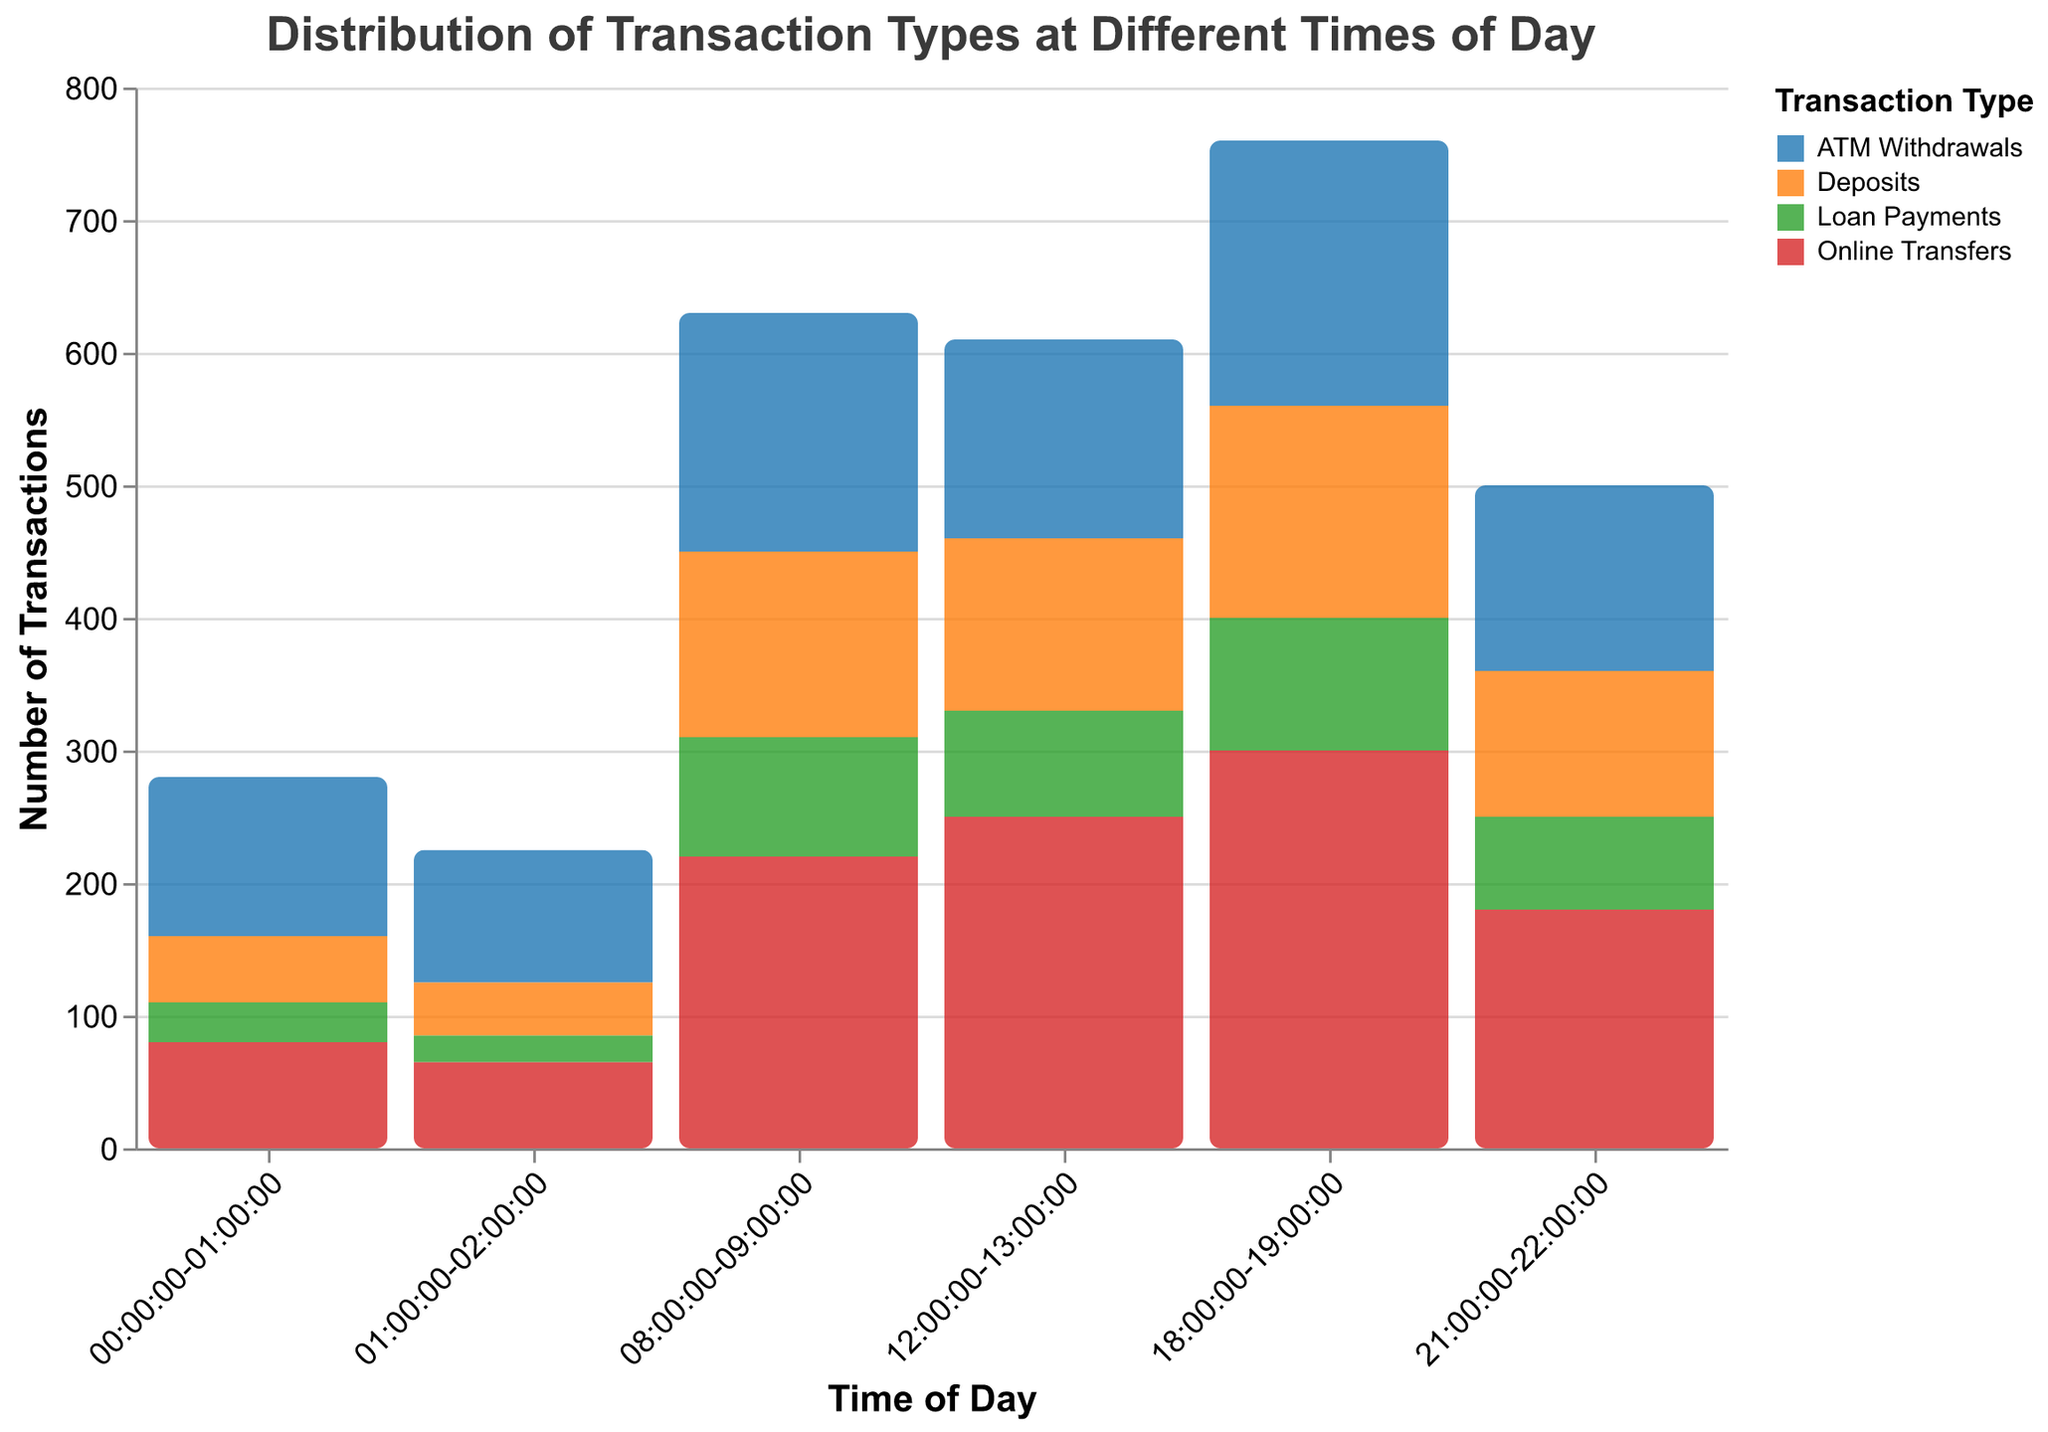What is the title of the figure? The title of the figure is shown at the top in larger and bolder font compared to other text elements. It reads "Distribution of Transaction Types at Different Times of Day".
Answer: Distribution of Transaction Types at Different Times of Day What are the labels on the x-axis? The labels on the x-axis represent different times of the day, formatted as time intervals. They can be seen directly under the x-axis and include intervals like "00:00:00-01:00:00", "08:00:00-09:00:00", etc.
Answer: Time intervals, e.g., "00:00:00-01:00:00", "08:00:00-09:00:00" Which transaction type has the highest count at 18:00:00-19:00:00? We need to look at the bars corresponding to the 18:00:00-19:00:00 interval and compare their heights. The highest bar represents Online Transfers with a transaction count of 300.
Answer: Online Transfers What is the total number of transactions between 12:00:00 and 13:00:00? Sum up the transaction counts for all types (ATM Withdrawals, Online Transfers, Deposits, Loan Payments) during the 12:00:00-13:00:00 interval: 150 + 250 + 130 + 80 = 610.
Answer: 610 How do ATM Withdrawals at 21:00:00-22:00:00 compare to those at 00:00:00-01:00:00? Compare the heights of the bars for ATM Withdrawals at 21:00:00-22:00:00 and 00:00:00-01:00:00. The count is 140 at 21:00:00-22:00:00 and 120 at 00:00:00-01:00:00, so there are more ATM Withdrawals at 21:00:00-22:00:00.
Answer: More at 21:00:00-22:00:00 During which time interval does Loan Payments have the lowest transaction count? Compare the heights of the bars representing Loan Payments across all time intervals. The lowest bar is at the 01:00:00-02:00:00 interval with a count of 20.
Answer: 01:00:00-02:00:00 What is the ratio of Online Transfers to Deposits at 08:00:00-09:00:00? Find the counts for Online Transfers (220) and Deposits (140) at 08:00:00-09:00:00, then divide them: 220 / 140 = 1.57.
Answer: 1.57 Which time interval has the most total transactions? Sum the transaction counts for all types at each interval and compare them. The 18:00:00-19:00:00 interval has the most total transactions: 200 + 300 + 160 + 100 = 760.
Answer: 18:00:00-19:00:00 What is the difference in the number of Deposits between 12:00:00-13:00:00 and 18:00:00-19:00:00? Subtract the number of Deposits at 12:00:00-13:00:00 (130) from the number at 18:00:00-19:00:00 (160): 160 - 130 = 30.
Answer: 30 